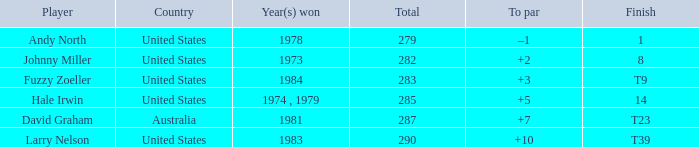Which player finished at +10? Larry Nelson. 